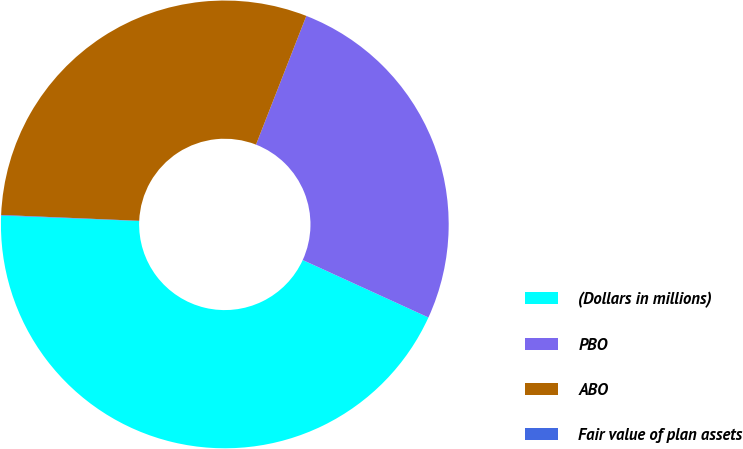Convert chart. <chart><loc_0><loc_0><loc_500><loc_500><pie_chart><fcel>(Dollars in millions)<fcel>PBO<fcel>ABO<fcel>Fair value of plan assets<nl><fcel>43.81%<fcel>25.89%<fcel>30.26%<fcel>0.04%<nl></chart> 